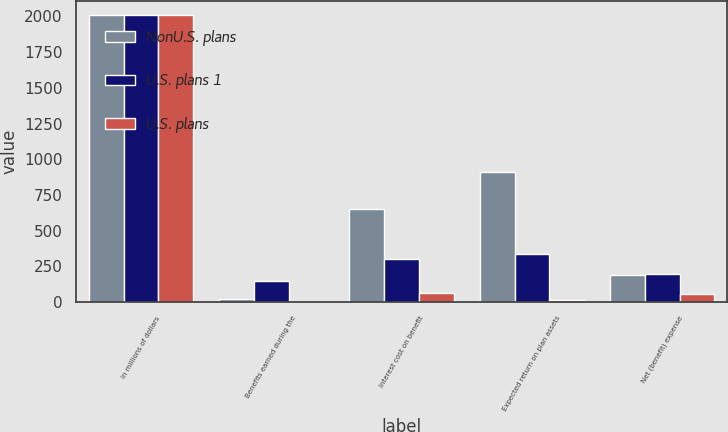Convert chart. <chart><loc_0><loc_0><loc_500><loc_500><stacked_bar_chart><ecel><fcel>In millions of dollars<fcel>Benefits earned during the<fcel>Interest cost on benefit<fcel>Expected return on plan assets<fcel>Net (benefit) expense<nl><fcel>NonU.S. plans<fcel>2009<fcel>18<fcel>649<fcel>912<fcel>189<nl><fcel>U.S. plans 1<fcel>2009<fcel>148<fcel>301<fcel>336<fcel>198<nl><fcel>U.S. plans<fcel>2009<fcel>1<fcel>61<fcel>10<fcel>53<nl></chart> 